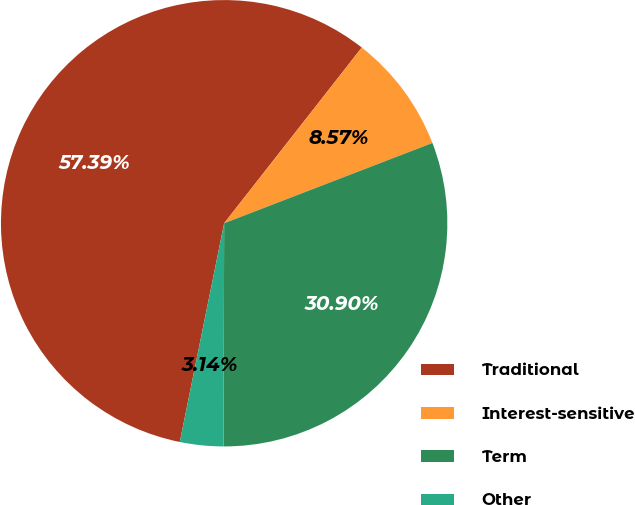<chart> <loc_0><loc_0><loc_500><loc_500><pie_chart><fcel>Traditional<fcel>Interest-sensitive<fcel>Term<fcel>Other<nl><fcel>57.39%<fcel>8.57%<fcel>30.9%<fcel>3.14%<nl></chart> 